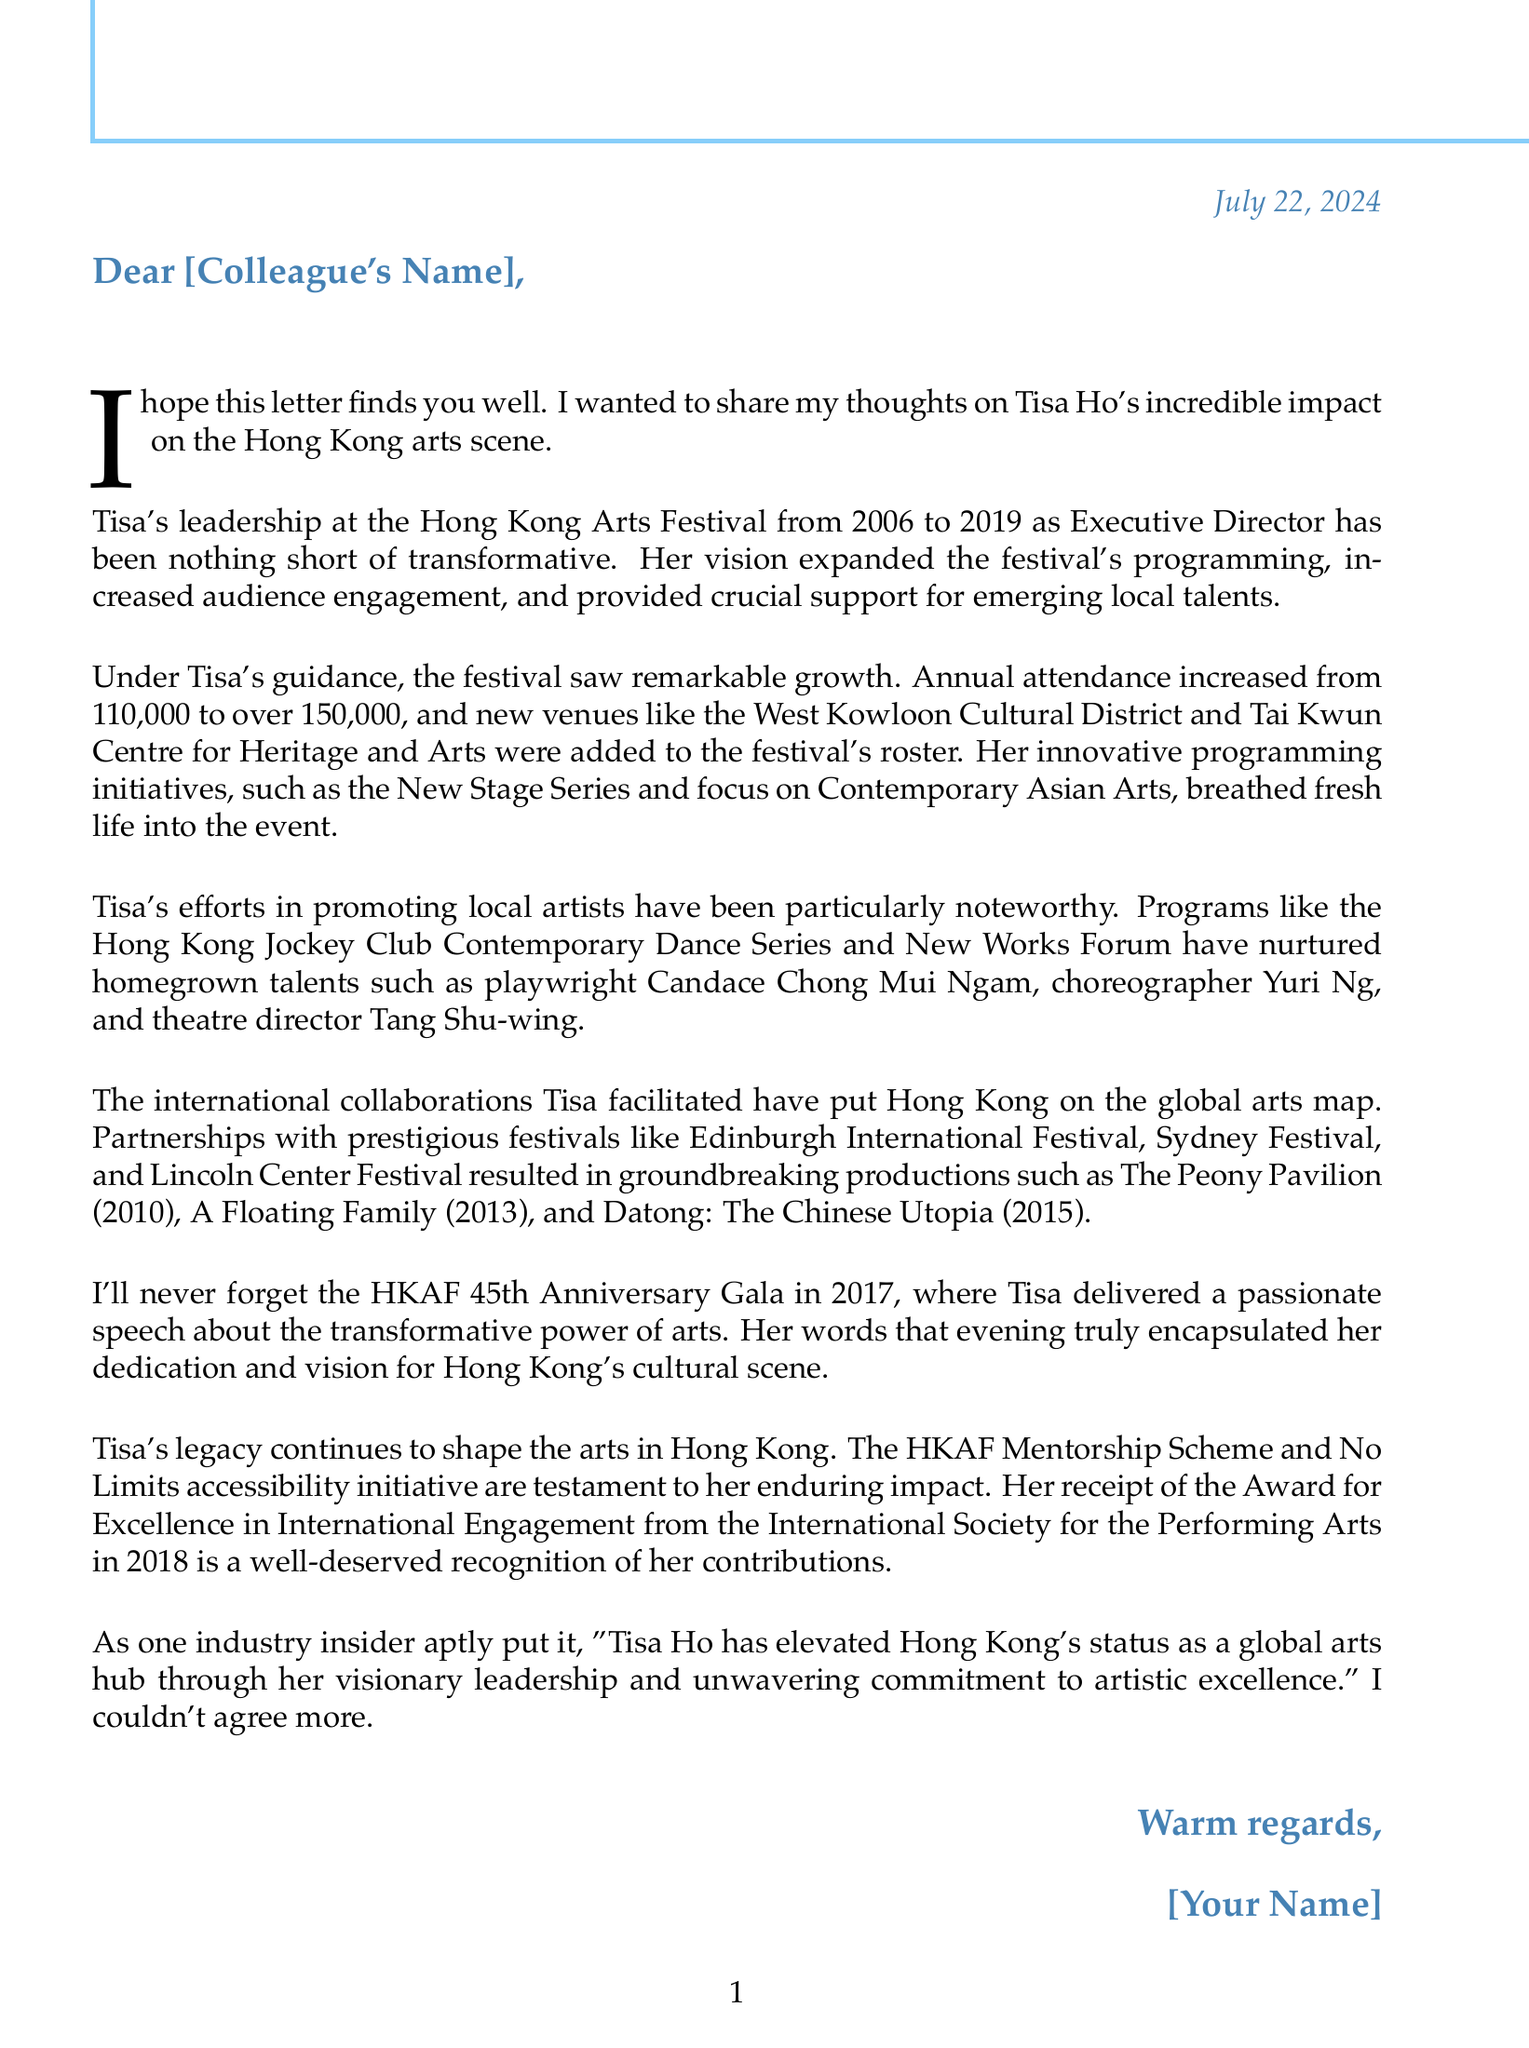What was Tisa Ho's position at the Hong Kong Arts Festival? Tisa Ho served as the Executive Director of the Hong Kong Arts Festival.
Answer: Executive Director What years was Tisa Ho active in her role? Tisa Ho was active from 2006 to 2019 at the Hong Kong Arts Festival.
Answer: 2006-2019 What was the annual attendance increase during Tisa's leadership? The annual attendance at the festival increased from 110,000 to over 150,000.
Answer: Over 150,000 Name a successful local artist supported by Tisa. One of the successful artists mentioned is playwright Candace Chong Mui Ngam.
Answer: Candace Chong Mui Ngam Which international festival did Tisa collaborate with for the production "A Floating Family"? Tisa collaborated with the Sydney Festival for this production.
Answer: Sydney Festival What notable speech did Tisa give in 2017? Tisa delivered a passionate speech about the transformative power of arts at the HKAF 45th Anniversary Gala.
Answer: Transformative power of arts What recognition did Tisa receive in 2018? Tisa received the Award for Excellence in International Engagement from the International Society for the Performing Arts.
Answer: Award for Excellence in International Engagement Which venue was expanded under Tisa's guidance? The West Kowloon Cultural District was one of the venues expanded during her leadership.
Answer: West Kowloon Cultural District What initiative continues Tisa's legacy in supporting local artists? The HKAF Mentorship Scheme is one of the initiatives that continues her legacy.
Answer: HKAF Mentorship Scheme 